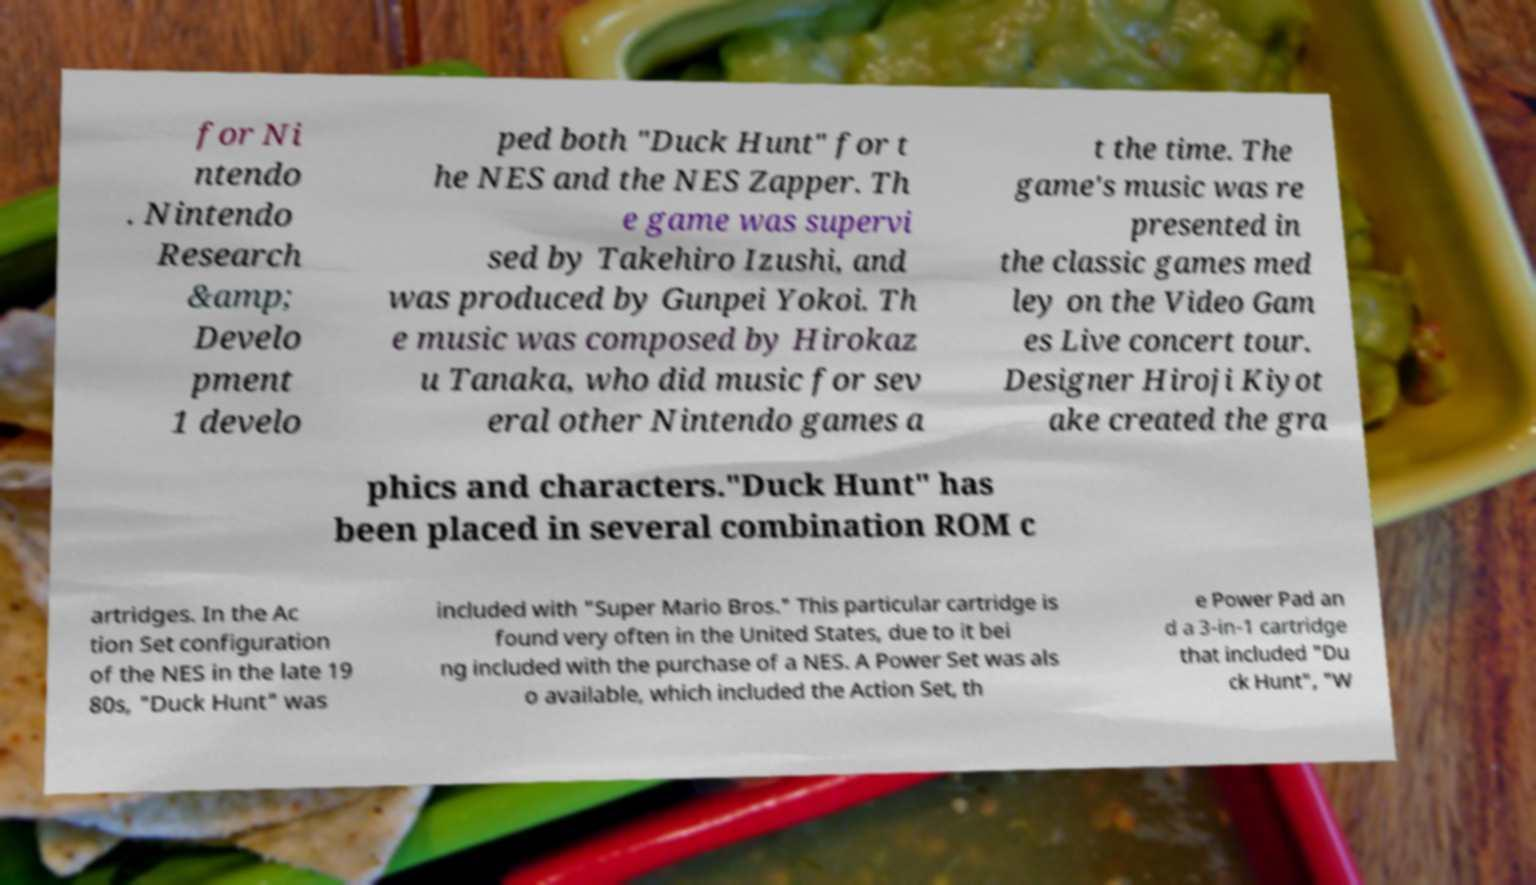Could you assist in decoding the text presented in this image and type it out clearly? for Ni ntendo . Nintendo Research &amp; Develo pment 1 develo ped both "Duck Hunt" for t he NES and the NES Zapper. Th e game was supervi sed by Takehiro Izushi, and was produced by Gunpei Yokoi. Th e music was composed by Hirokaz u Tanaka, who did music for sev eral other Nintendo games a t the time. The game's music was re presented in the classic games med ley on the Video Gam es Live concert tour. Designer Hiroji Kiyot ake created the gra phics and characters."Duck Hunt" has been placed in several combination ROM c artridges. In the Ac tion Set configuration of the NES in the late 19 80s, "Duck Hunt" was included with "Super Mario Bros." This particular cartridge is found very often in the United States, due to it bei ng included with the purchase of a NES. A Power Set was als o available, which included the Action Set, th e Power Pad an d a 3-in-1 cartridge that included "Du ck Hunt", "W 